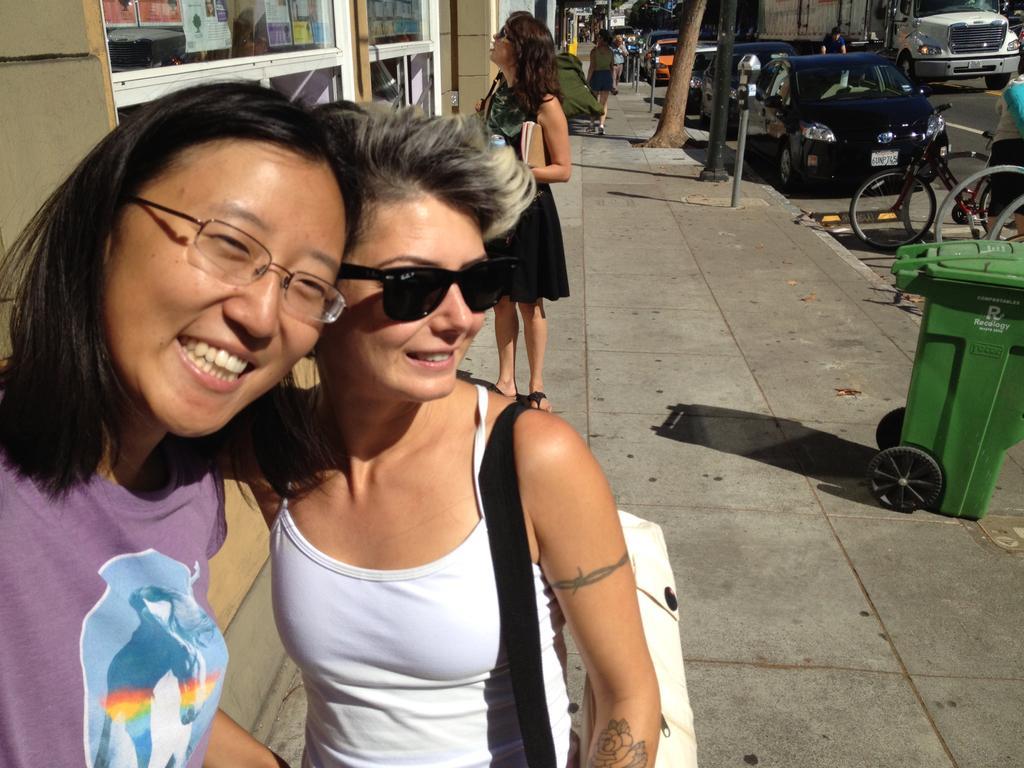How would you summarize this image in a sentence or two? In this image there are a few people standing with a smile on their face, behind them there are few vehicles on the road, in front of them there are bicycles and a dustbin. In the background there are buildings and trees. 